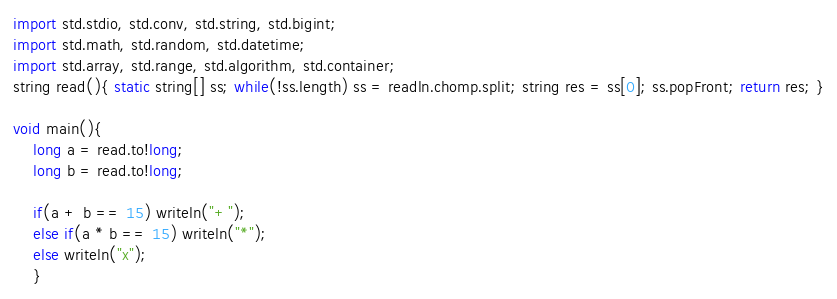Convert code to text. <code><loc_0><loc_0><loc_500><loc_500><_D_>import std.stdio, std.conv, std.string, std.bigint;
import std.math, std.random, std.datetime;
import std.array, std.range, std.algorithm, std.container;
string read(){ static string[] ss; while(!ss.length) ss = readln.chomp.split; string res = ss[0]; ss.popFront; return res; }

void main(){
	long a = read.to!long;
	long b = read.to!long;
	
	if(a + b == 15) writeln("+");
	else if(a * b == 15) writeln("*");
	else writeln("x");
	}</code> 